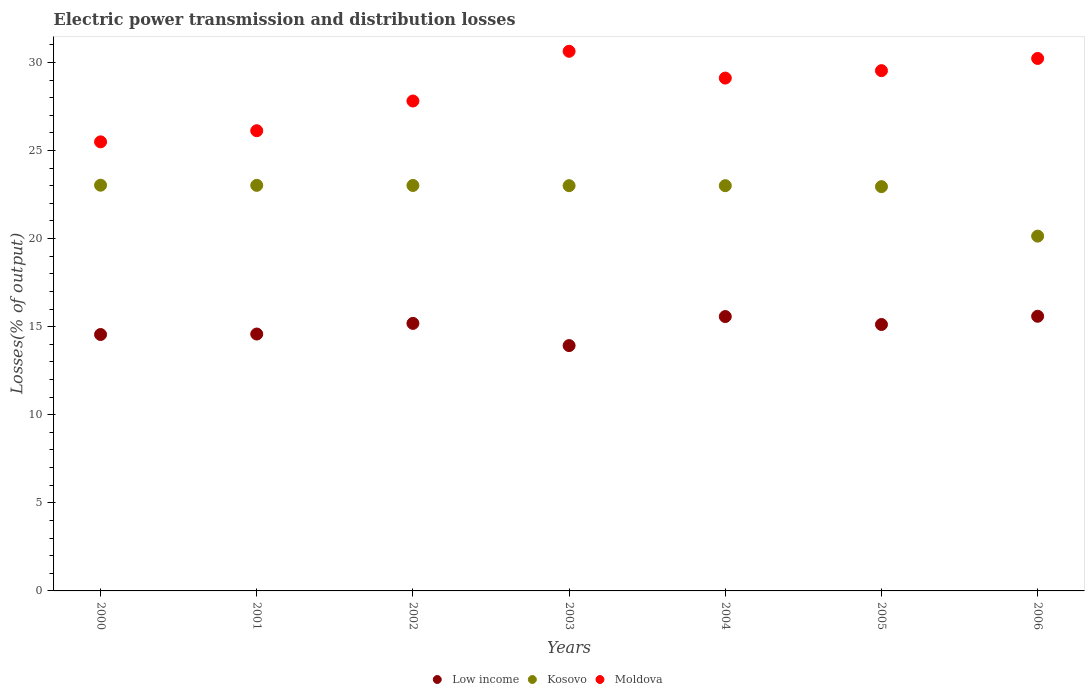Is the number of dotlines equal to the number of legend labels?
Offer a very short reply. Yes. What is the electric power transmission and distribution losses in Kosovo in 2002?
Provide a short and direct response. 23.01. Across all years, what is the maximum electric power transmission and distribution losses in Low income?
Your response must be concise. 15.59. Across all years, what is the minimum electric power transmission and distribution losses in Low income?
Keep it short and to the point. 13.93. In which year was the electric power transmission and distribution losses in Moldova maximum?
Offer a very short reply. 2003. What is the total electric power transmission and distribution losses in Moldova in the graph?
Give a very brief answer. 198.92. What is the difference between the electric power transmission and distribution losses in Low income in 2000 and that in 2006?
Provide a short and direct response. -1.04. What is the difference between the electric power transmission and distribution losses in Moldova in 2004 and the electric power transmission and distribution losses in Kosovo in 2001?
Your answer should be compact. 6.09. What is the average electric power transmission and distribution losses in Kosovo per year?
Make the answer very short. 22.59. In the year 2002, what is the difference between the electric power transmission and distribution losses in Low income and electric power transmission and distribution losses in Kosovo?
Keep it short and to the point. -7.83. In how many years, is the electric power transmission and distribution losses in Moldova greater than 4 %?
Your answer should be compact. 7. What is the ratio of the electric power transmission and distribution losses in Low income in 2003 to that in 2006?
Provide a succinct answer. 0.89. Is the electric power transmission and distribution losses in Kosovo in 2004 less than that in 2005?
Offer a very short reply. No. Is the difference between the electric power transmission and distribution losses in Low income in 2002 and 2004 greater than the difference between the electric power transmission and distribution losses in Kosovo in 2002 and 2004?
Give a very brief answer. No. What is the difference between the highest and the second highest electric power transmission and distribution losses in Moldova?
Ensure brevity in your answer.  0.41. What is the difference between the highest and the lowest electric power transmission and distribution losses in Kosovo?
Keep it short and to the point. 2.89. In how many years, is the electric power transmission and distribution losses in Moldova greater than the average electric power transmission and distribution losses in Moldova taken over all years?
Give a very brief answer. 4. Is the sum of the electric power transmission and distribution losses in Moldova in 2001 and 2002 greater than the maximum electric power transmission and distribution losses in Kosovo across all years?
Ensure brevity in your answer.  Yes. Does the electric power transmission and distribution losses in Moldova monotonically increase over the years?
Keep it short and to the point. No. Is the electric power transmission and distribution losses in Moldova strictly greater than the electric power transmission and distribution losses in Kosovo over the years?
Keep it short and to the point. Yes. How many dotlines are there?
Make the answer very short. 3. How many years are there in the graph?
Give a very brief answer. 7. What is the difference between two consecutive major ticks on the Y-axis?
Make the answer very short. 5. Does the graph contain any zero values?
Keep it short and to the point. No. What is the title of the graph?
Your answer should be very brief. Electric power transmission and distribution losses. What is the label or title of the X-axis?
Provide a succinct answer. Years. What is the label or title of the Y-axis?
Offer a terse response. Losses(% of output). What is the Losses(% of output) of Low income in 2000?
Keep it short and to the point. 14.55. What is the Losses(% of output) of Kosovo in 2000?
Your response must be concise. 23.03. What is the Losses(% of output) in Moldova in 2000?
Your answer should be very brief. 25.49. What is the Losses(% of output) of Low income in 2001?
Provide a succinct answer. 14.58. What is the Losses(% of output) in Kosovo in 2001?
Provide a succinct answer. 23.02. What is the Losses(% of output) of Moldova in 2001?
Offer a terse response. 26.12. What is the Losses(% of output) in Low income in 2002?
Provide a short and direct response. 15.19. What is the Losses(% of output) of Kosovo in 2002?
Offer a very short reply. 23.01. What is the Losses(% of output) in Moldova in 2002?
Keep it short and to the point. 27.81. What is the Losses(% of output) of Low income in 2003?
Your response must be concise. 13.93. What is the Losses(% of output) of Kosovo in 2003?
Keep it short and to the point. 23. What is the Losses(% of output) in Moldova in 2003?
Give a very brief answer. 30.63. What is the Losses(% of output) of Low income in 2004?
Make the answer very short. 15.57. What is the Losses(% of output) in Kosovo in 2004?
Provide a short and direct response. 23. What is the Losses(% of output) of Moldova in 2004?
Offer a terse response. 29.11. What is the Losses(% of output) of Low income in 2005?
Provide a short and direct response. 15.12. What is the Losses(% of output) of Kosovo in 2005?
Offer a very short reply. 22.95. What is the Losses(% of output) of Moldova in 2005?
Your response must be concise. 29.53. What is the Losses(% of output) of Low income in 2006?
Offer a very short reply. 15.59. What is the Losses(% of output) of Kosovo in 2006?
Ensure brevity in your answer.  20.14. What is the Losses(% of output) of Moldova in 2006?
Your response must be concise. 30.23. Across all years, what is the maximum Losses(% of output) in Low income?
Give a very brief answer. 15.59. Across all years, what is the maximum Losses(% of output) in Kosovo?
Provide a short and direct response. 23.03. Across all years, what is the maximum Losses(% of output) of Moldova?
Provide a succinct answer. 30.63. Across all years, what is the minimum Losses(% of output) of Low income?
Provide a succinct answer. 13.93. Across all years, what is the minimum Losses(% of output) of Kosovo?
Your response must be concise. 20.14. Across all years, what is the minimum Losses(% of output) in Moldova?
Your answer should be compact. 25.49. What is the total Losses(% of output) in Low income in the graph?
Your response must be concise. 104.54. What is the total Losses(% of output) in Kosovo in the graph?
Provide a succinct answer. 158.16. What is the total Losses(% of output) in Moldova in the graph?
Your answer should be very brief. 198.92. What is the difference between the Losses(% of output) of Low income in 2000 and that in 2001?
Offer a terse response. -0.03. What is the difference between the Losses(% of output) in Kosovo in 2000 and that in 2001?
Your response must be concise. 0.01. What is the difference between the Losses(% of output) in Moldova in 2000 and that in 2001?
Make the answer very short. -0.63. What is the difference between the Losses(% of output) in Low income in 2000 and that in 2002?
Provide a short and direct response. -0.63. What is the difference between the Losses(% of output) of Kosovo in 2000 and that in 2002?
Offer a terse response. 0.02. What is the difference between the Losses(% of output) in Moldova in 2000 and that in 2002?
Offer a terse response. -2.32. What is the difference between the Losses(% of output) in Low income in 2000 and that in 2003?
Give a very brief answer. 0.63. What is the difference between the Losses(% of output) of Kosovo in 2000 and that in 2003?
Provide a succinct answer. 0.03. What is the difference between the Losses(% of output) of Moldova in 2000 and that in 2003?
Provide a succinct answer. -5.14. What is the difference between the Losses(% of output) of Low income in 2000 and that in 2004?
Offer a very short reply. -1.02. What is the difference between the Losses(% of output) of Kosovo in 2000 and that in 2004?
Offer a very short reply. 0.03. What is the difference between the Losses(% of output) in Moldova in 2000 and that in 2004?
Offer a terse response. -3.62. What is the difference between the Losses(% of output) of Low income in 2000 and that in 2005?
Your answer should be very brief. -0.57. What is the difference between the Losses(% of output) of Kosovo in 2000 and that in 2005?
Give a very brief answer. 0.08. What is the difference between the Losses(% of output) of Moldova in 2000 and that in 2005?
Your answer should be very brief. -4.04. What is the difference between the Losses(% of output) in Low income in 2000 and that in 2006?
Make the answer very short. -1.04. What is the difference between the Losses(% of output) in Kosovo in 2000 and that in 2006?
Give a very brief answer. 2.89. What is the difference between the Losses(% of output) of Moldova in 2000 and that in 2006?
Your answer should be very brief. -4.73. What is the difference between the Losses(% of output) of Low income in 2001 and that in 2002?
Your answer should be very brief. -0.6. What is the difference between the Losses(% of output) of Kosovo in 2001 and that in 2002?
Your answer should be very brief. 0.01. What is the difference between the Losses(% of output) in Moldova in 2001 and that in 2002?
Your response must be concise. -1.69. What is the difference between the Losses(% of output) in Low income in 2001 and that in 2003?
Keep it short and to the point. 0.66. What is the difference between the Losses(% of output) of Kosovo in 2001 and that in 2003?
Make the answer very short. 0.02. What is the difference between the Losses(% of output) in Moldova in 2001 and that in 2003?
Offer a very short reply. -4.51. What is the difference between the Losses(% of output) of Low income in 2001 and that in 2004?
Your answer should be compact. -0.99. What is the difference between the Losses(% of output) in Kosovo in 2001 and that in 2004?
Your answer should be compact. 0.02. What is the difference between the Losses(% of output) in Moldova in 2001 and that in 2004?
Provide a short and direct response. -2.99. What is the difference between the Losses(% of output) in Low income in 2001 and that in 2005?
Give a very brief answer. -0.54. What is the difference between the Losses(% of output) in Kosovo in 2001 and that in 2005?
Keep it short and to the point. 0.07. What is the difference between the Losses(% of output) of Moldova in 2001 and that in 2005?
Keep it short and to the point. -3.41. What is the difference between the Losses(% of output) of Low income in 2001 and that in 2006?
Make the answer very short. -1.01. What is the difference between the Losses(% of output) in Kosovo in 2001 and that in 2006?
Your answer should be very brief. 2.88. What is the difference between the Losses(% of output) in Moldova in 2001 and that in 2006?
Give a very brief answer. -4.1. What is the difference between the Losses(% of output) in Low income in 2002 and that in 2003?
Ensure brevity in your answer.  1.26. What is the difference between the Losses(% of output) of Kosovo in 2002 and that in 2003?
Your answer should be compact. 0.01. What is the difference between the Losses(% of output) in Moldova in 2002 and that in 2003?
Ensure brevity in your answer.  -2.82. What is the difference between the Losses(% of output) in Low income in 2002 and that in 2004?
Offer a terse response. -0.39. What is the difference between the Losses(% of output) of Kosovo in 2002 and that in 2004?
Make the answer very short. 0.01. What is the difference between the Losses(% of output) of Moldova in 2002 and that in 2004?
Provide a short and direct response. -1.3. What is the difference between the Losses(% of output) in Low income in 2002 and that in 2005?
Provide a short and direct response. 0.06. What is the difference between the Losses(% of output) in Kosovo in 2002 and that in 2005?
Your answer should be compact. 0.07. What is the difference between the Losses(% of output) of Moldova in 2002 and that in 2005?
Ensure brevity in your answer.  -1.72. What is the difference between the Losses(% of output) in Low income in 2002 and that in 2006?
Make the answer very short. -0.4. What is the difference between the Losses(% of output) in Kosovo in 2002 and that in 2006?
Offer a terse response. 2.88. What is the difference between the Losses(% of output) of Moldova in 2002 and that in 2006?
Make the answer very short. -2.42. What is the difference between the Losses(% of output) in Low income in 2003 and that in 2004?
Your answer should be compact. -1.65. What is the difference between the Losses(% of output) in Kosovo in 2003 and that in 2004?
Offer a terse response. -0. What is the difference between the Losses(% of output) of Moldova in 2003 and that in 2004?
Your response must be concise. 1.52. What is the difference between the Losses(% of output) in Low income in 2003 and that in 2005?
Provide a succinct answer. -1.2. What is the difference between the Losses(% of output) in Kosovo in 2003 and that in 2005?
Give a very brief answer. 0.06. What is the difference between the Losses(% of output) in Moldova in 2003 and that in 2005?
Offer a very short reply. 1.1. What is the difference between the Losses(% of output) in Low income in 2003 and that in 2006?
Provide a succinct answer. -1.66. What is the difference between the Losses(% of output) of Kosovo in 2003 and that in 2006?
Keep it short and to the point. 2.86. What is the difference between the Losses(% of output) in Moldova in 2003 and that in 2006?
Offer a terse response. 0.41. What is the difference between the Losses(% of output) of Low income in 2004 and that in 2005?
Give a very brief answer. 0.45. What is the difference between the Losses(% of output) in Kosovo in 2004 and that in 2005?
Keep it short and to the point. 0.06. What is the difference between the Losses(% of output) of Moldova in 2004 and that in 2005?
Your answer should be very brief. -0.42. What is the difference between the Losses(% of output) in Low income in 2004 and that in 2006?
Offer a terse response. -0.02. What is the difference between the Losses(% of output) in Kosovo in 2004 and that in 2006?
Your answer should be compact. 2.86. What is the difference between the Losses(% of output) of Moldova in 2004 and that in 2006?
Provide a succinct answer. -1.11. What is the difference between the Losses(% of output) in Low income in 2005 and that in 2006?
Make the answer very short. -0.47. What is the difference between the Losses(% of output) in Kosovo in 2005 and that in 2006?
Make the answer very short. 2.81. What is the difference between the Losses(% of output) in Moldova in 2005 and that in 2006?
Make the answer very short. -0.69. What is the difference between the Losses(% of output) in Low income in 2000 and the Losses(% of output) in Kosovo in 2001?
Give a very brief answer. -8.47. What is the difference between the Losses(% of output) in Low income in 2000 and the Losses(% of output) in Moldova in 2001?
Provide a short and direct response. -11.57. What is the difference between the Losses(% of output) in Kosovo in 2000 and the Losses(% of output) in Moldova in 2001?
Make the answer very short. -3.09. What is the difference between the Losses(% of output) in Low income in 2000 and the Losses(% of output) in Kosovo in 2002?
Make the answer very short. -8.46. What is the difference between the Losses(% of output) in Low income in 2000 and the Losses(% of output) in Moldova in 2002?
Your answer should be compact. -13.25. What is the difference between the Losses(% of output) in Kosovo in 2000 and the Losses(% of output) in Moldova in 2002?
Ensure brevity in your answer.  -4.78. What is the difference between the Losses(% of output) of Low income in 2000 and the Losses(% of output) of Kosovo in 2003?
Your response must be concise. -8.45. What is the difference between the Losses(% of output) in Low income in 2000 and the Losses(% of output) in Moldova in 2003?
Make the answer very short. -16.08. What is the difference between the Losses(% of output) of Kosovo in 2000 and the Losses(% of output) of Moldova in 2003?
Your answer should be compact. -7.6. What is the difference between the Losses(% of output) in Low income in 2000 and the Losses(% of output) in Kosovo in 2004?
Ensure brevity in your answer.  -8.45. What is the difference between the Losses(% of output) of Low income in 2000 and the Losses(% of output) of Moldova in 2004?
Your response must be concise. -14.56. What is the difference between the Losses(% of output) of Kosovo in 2000 and the Losses(% of output) of Moldova in 2004?
Ensure brevity in your answer.  -6.08. What is the difference between the Losses(% of output) of Low income in 2000 and the Losses(% of output) of Kosovo in 2005?
Ensure brevity in your answer.  -8.39. What is the difference between the Losses(% of output) in Low income in 2000 and the Losses(% of output) in Moldova in 2005?
Offer a very short reply. -14.98. What is the difference between the Losses(% of output) of Kosovo in 2000 and the Losses(% of output) of Moldova in 2005?
Offer a very short reply. -6.5. What is the difference between the Losses(% of output) of Low income in 2000 and the Losses(% of output) of Kosovo in 2006?
Ensure brevity in your answer.  -5.59. What is the difference between the Losses(% of output) in Low income in 2000 and the Losses(% of output) in Moldova in 2006?
Offer a very short reply. -15.67. What is the difference between the Losses(% of output) of Kosovo in 2000 and the Losses(% of output) of Moldova in 2006?
Give a very brief answer. -7.2. What is the difference between the Losses(% of output) in Low income in 2001 and the Losses(% of output) in Kosovo in 2002?
Provide a succinct answer. -8.43. What is the difference between the Losses(% of output) of Low income in 2001 and the Losses(% of output) of Moldova in 2002?
Keep it short and to the point. -13.23. What is the difference between the Losses(% of output) of Kosovo in 2001 and the Losses(% of output) of Moldova in 2002?
Your answer should be very brief. -4.79. What is the difference between the Losses(% of output) in Low income in 2001 and the Losses(% of output) in Kosovo in 2003?
Provide a short and direct response. -8.42. What is the difference between the Losses(% of output) in Low income in 2001 and the Losses(% of output) in Moldova in 2003?
Make the answer very short. -16.05. What is the difference between the Losses(% of output) in Kosovo in 2001 and the Losses(% of output) in Moldova in 2003?
Provide a succinct answer. -7.61. What is the difference between the Losses(% of output) of Low income in 2001 and the Losses(% of output) of Kosovo in 2004?
Ensure brevity in your answer.  -8.42. What is the difference between the Losses(% of output) in Low income in 2001 and the Losses(% of output) in Moldova in 2004?
Provide a succinct answer. -14.53. What is the difference between the Losses(% of output) in Kosovo in 2001 and the Losses(% of output) in Moldova in 2004?
Offer a terse response. -6.09. What is the difference between the Losses(% of output) of Low income in 2001 and the Losses(% of output) of Kosovo in 2005?
Give a very brief answer. -8.37. What is the difference between the Losses(% of output) of Low income in 2001 and the Losses(% of output) of Moldova in 2005?
Your answer should be compact. -14.95. What is the difference between the Losses(% of output) in Kosovo in 2001 and the Losses(% of output) in Moldova in 2005?
Your answer should be very brief. -6.51. What is the difference between the Losses(% of output) of Low income in 2001 and the Losses(% of output) of Kosovo in 2006?
Make the answer very short. -5.56. What is the difference between the Losses(% of output) in Low income in 2001 and the Losses(% of output) in Moldova in 2006?
Ensure brevity in your answer.  -15.64. What is the difference between the Losses(% of output) of Kosovo in 2001 and the Losses(% of output) of Moldova in 2006?
Your answer should be compact. -7.2. What is the difference between the Losses(% of output) of Low income in 2002 and the Losses(% of output) of Kosovo in 2003?
Your answer should be very brief. -7.82. What is the difference between the Losses(% of output) of Low income in 2002 and the Losses(% of output) of Moldova in 2003?
Provide a succinct answer. -15.45. What is the difference between the Losses(% of output) in Kosovo in 2002 and the Losses(% of output) in Moldova in 2003?
Make the answer very short. -7.62. What is the difference between the Losses(% of output) of Low income in 2002 and the Losses(% of output) of Kosovo in 2004?
Provide a short and direct response. -7.82. What is the difference between the Losses(% of output) of Low income in 2002 and the Losses(% of output) of Moldova in 2004?
Offer a very short reply. -13.92. What is the difference between the Losses(% of output) of Kosovo in 2002 and the Losses(% of output) of Moldova in 2004?
Provide a succinct answer. -6.1. What is the difference between the Losses(% of output) of Low income in 2002 and the Losses(% of output) of Kosovo in 2005?
Provide a short and direct response. -7.76. What is the difference between the Losses(% of output) of Low income in 2002 and the Losses(% of output) of Moldova in 2005?
Provide a short and direct response. -14.35. What is the difference between the Losses(% of output) in Kosovo in 2002 and the Losses(% of output) in Moldova in 2005?
Ensure brevity in your answer.  -6.52. What is the difference between the Losses(% of output) in Low income in 2002 and the Losses(% of output) in Kosovo in 2006?
Your response must be concise. -4.95. What is the difference between the Losses(% of output) in Low income in 2002 and the Losses(% of output) in Moldova in 2006?
Offer a very short reply. -15.04. What is the difference between the Losses(% of output) in Kosovo in 2002 and the Losses(% of output) in Moldova in 2006?
Ensure brevity in your answer.  -7.21. What is the difference between the Losses(% of output) in Low income in 2003 and the Losses(% of output) in Kosovo in 2004?
Offer a terse response. -9.08. What is the difference between the Losses(% of output) of Low income in 2003 and the Losses(% of output) of Moldova in 2004?
Keep it short and to the point. -15.18. What is the difference between the Losses(% of output) in Kosovo in 2003 and the Losses(% of output) in Moldova in 2004?
Your answer should be compact. -6.11. What is the difference between the Losses(% of output) in Low income in 2003 and the Losses(% of output) in Kosovo in 2005?
Offer a terse response. -9.02. What is the difference between the Losses(% of output) in Low income in 2003 and the Losses(% of output) in Moldova in 2005?
Offer a very short reply. -15.61. What is the difference between the Losses(% of output) in Kosovo in 2003 and the Losses(% of output) in Moldova in 2005?
Make the answer very short. -6.53. What is the difference between the Losses(% of output) in Low income in 2003 and the Losses(% of output) in Kosovo in 2006?
Provide a short and direct response. -6.21. What is the difference between the Losses(% of output) of Low income in 2003 and the Losses(% of output) of Moldova in 2006?
Provide a succinct answer. -16.3. What is the difference between the Losses(% of output) in Kosovo in 2003 and the Losses(% of output) in Moldova in 2006?
Ensure brevity in your answer.  -7.22. What is the difference between the Losses(% of output) of Low income in 2004 and the Losses(% of output) of Kosovo in 2005?
Keep it short and to the point. -7.37. What is the difference between the Losses(% of output) in Low income in 2004 and the Losses(% of output) in Moldova in 2005?
Offer a terse response. -13.96. What is the difference between the Losses(% of output) in Kosovo in 2004 and the Losses(% of output) in Moldova in 2005?
Offer a very short reply. -6.53. What is the difference between the Losses(% of output) in Low income in 2004 and the Losses(% of output) in Kosovo in 2006?
Your response must be concise. -4.57. What is the difference between the Losses(% of output) of Low income in 2004 and the Losses(% of output) of Moldova in 2006?
Your answer should be compact. -14.65. What is the difference between the Losses(% of output) of Kosovo in 2004 and the Losses(% of output) of Moldova in 2006?
Your answer should be very brief. -7.22. What is the difference between the Losses(% of output) in Low income in 2005 and the Losses(% of output) in Kosovo in 2006?
Your answer should be compact. -5.02. What is the difference between the Losses(% of output) in Low income in 2005 and the Losses(% of output) in Moldova in 2006?
Give a very brief answer. -15.1. What is the difference between the Losses(% of output) of Kosovo in 2005 and the Losses(% of output) of Moldova in 2006?
Ensure brevity in your answer.  -7.28. What is the average Losses(% of output) in Low income per year?
Your response must be concise. 14.93. What is the average Losses(% of output) in Kosovo per year?
Provide a short and direct response. 22.59. What is the average Losses(% of output) in Moldova per year?
Offer a terse response. 28.42. In the year 2000, what is the difference between the Losses(% of output) of Low income and Losses(% of output) of Kosovo?
Your answer should be compact. -8.48. In the year 2000, what is the difference between the Losses(% of output) of Low income and Losses(% of output) of Moldova?
Keep it short and to the point. -10.94. In the year 2000, what is the difference between the Losses(% of output) of Kosovo and Losses(% of output) of Moldova?
Ensure brevity in your answer.  -2.46. In the year 2001, what is the difference between the Losses(% of output) in Low income and Losses(% of output) in Kosovo?
Give a very brief answer. -8.44. In the year 2001, what is the difference between the Losses(% of output) of Low income and Losses(% of output) of Moldova?
Offer a very short reply. -11.54. In the year 2001, what is the difference between the Losses(% of output) in Kosovo and Losses(% of output) in Moldova?
Provide a succinct answer. -3.1. In the year 2002, what is the difference between the Losses(% of output) in Low income and Losses(% of output) in Kosovo?
Offer a terse response. -7.83. In the year 2002, what is the difference between the Losses(% of output) of Low income and Losses(% of output) of Moldova?
Provide a short and direct response. -12.62. In the year 2002, what is the difference between the Losses(% of output) of Kosovo and Losses(% of output) of Moldova?
Provide a succinct answer. -4.79. In the year 2003, what is the difference between the Losses(% of output) in Low income and Losses(% of output) in Kosovo?
Ensure brevity in your answer.  -9.08. In the year 2003, what is the difference between the Losses(% of output) of Low income and Losses(% of output) of Moldova?
Provide a succinct answer. -16.71. In the year 2003, what is the difference between the Losses(% of output) of Kosovo and Losses(% of output) of Moldova?
Your answer should be compact. -7.63. In the year 2004, what is the difference between the Losses(% of output) in Low income and Losses(% of output) in Kosovo?
Keep it short and to the point. -7.43. In the year 2004, what is the difference between the Losses(% of output) in Low income and Losses(% of output) in Moldova?
Ensure brevity in your answer.  -13.54. In the year 2004, what is the difference between the Losses(% of output) in Kosovo and Losses(% of output) in Moldova?
Your answer should be compact. -6.11. In the year 2005, what is the difference between the Losses(% of output) of Low income and Losses(% of output) of Kosovo?
Your answer should be very brief. -7.82. In the year 2005, what is the difference between the Losses(% of output) in Low income and Losses(% of output) in Moldova?
Your response must be concise. -14.41. In the year 2005, what is the difference between the Losses(% of output) in Kosovo and Losses(% of output) in Moldova?
Offer a very short reply. -6.58. In the year 2006, what is the difference between the Losses(% of output) of Low income and Losses(% of output) of Kosovo?
Ensure brevity in your answer.  -4.55. In the year 2006, what is the difference between the Losses(% of output) in Low income and Losses(% of output) in Moldova?
Ensure brevity in your answer.  -14.63. In the year 2006, what is the difference between the Losses(% of output) in Kosovo and Losses(% of output) in Moldova?
Keep it short and to the point. -10.09. What is the ratio of the Losses(% of output) of Moldova in 2000 to that in 2001?
Ensure brevity in your answer.  0.98. What is the ratio of the Losses(% of output) in Low income in 2000 to that in 2002?
Give a very brief answer. 0.96. What is the ratio of the Losses(% of output) in Moldova in 2000 to that in 2002?
Offer a very short reply. 0.92. What is the ratio of the Losses(% of output) in Low income in 2000 to that in 2003?
Keep it short and to the point. 1.05. What is the ratio of the Losses(% of output) of Kosovo in 2000 to that in 2003?
Provide a short and direct response. 1. What is the ratio of the Losses(% of output) in Moldova in 2000 to that in 2003?
Offer a very short reply. 0.83. What is the ratio of the Losses(% of output) of Low income in 2000 to that in 2004?
Offer a very short reply. 0.93. What is the ratio of the Losses(% of output) of Kosovo in 2000 to that in 2004?
Your answer should be very brief. 1. What is the ratio of the Losses(% of output) of Moldova in 2000 to that in 2004?
Your answer should be very brief. 0.88. What is the ratio of the Losses(% of output) of Low income in 2000 to that in 2005?
Your answer should be compact. 0.96. What is the ratio of the Losses(% of output) of Moldova in 2000 to that in 2005?
Offer a terse response. 0.86. What is the ratio of the Losses(% of output) in Low income in 2000 to that in 2006?
Keep it short and to the point. 0.93. What is the ratio of the Losses(% of output) of Kosovo in 2000 to that in 2006?
Your answer should be compact. 1.14. What is the ratio of the Losses(% of output) in Moldova in 2000 to that in 2006?
Give a very brief answer. 0.84. What is the ratio of the Losses(% of output) in Low income in 2001 to that in 2002?
Offer a terse response. 0.96. What is the ratio of the Losses(% of output) in Moldova in 2001 to that in 2002?
Keep it short and to the point. 0.94. What is the ratio of the Losses(% of output) of Low income in 2001 to that in 2003?
Your answer should be compact. 1.05. What is the ratio of the Losses(% of output) of Moldova in 2001 to that in 2003?
Your response must be concise. 0.85. What is the ratio of the Losses(% of output) of Low income in 2001 to that in 2004?
Offer a terse response. 0.94. What is the ratio of the Losses(% of output) of Kosovo in 2001 to that in 2004?
Provide a succinct answer. 1. What is the ratio of the Losses(% of output) of Moldova in 2001 to that in 2004?
Ensure brevity in your answer.  0.9. What is the ratio of the Losses(% of output) of Low income in 2001 to that in 2005?
Offer a terse response. 0.96. What is the ratio of the Losses(% of output) of Moldova in 2001 to that in 2005?
Your answer should be compact. 0.88. What is the ratio of the Losses(% of output) in Low income in 2001 to that in 2006?
Provide a succinct answer. 0.94. What is the ratio of the Losses(% of output) of Kosovo in 2001 to that in 2006?
Your response must be concise. 1.14. What is the ratio of the Losses(% of output) of Moldova in 2001 to that in 2006?
Provide a short and direct response. 0.86. What is the ratio of the Losses(% of output) of Low income in 2002 to that in 2003?
Make the answer very short. 1.09. What is the ratio of the Losses(% of output) in Moldova in 2002 to that in 2003?
Your response must be concise. 0.91. What is the ratio of the Losses(% of output) of Low income in 2002 to that in 2004?
Your answer should be compact. 0.98. What is the ratio of the Losses(% of output) of Kosovo in 2002 to that in 2004?
Offer a very short reply. 1. What is the ratio of the Losses(% of output) in Moldova in 2002 to that in 2004?
Offer a terse response. 0.96. What is the ratio of the Losses(% of output) of Low income in 2002 to that in 2005?
Provide a short and direct response. 1. What is the ratio of the Losses(% of output) of Moldova in 2002 to that in 2005?
Make the answer very short. 0.94. What is the ratio of the Losses(% of output) in Low income in 2002 to that in 2006?
Your response must be concise. 0.97. What is the ratio of the Losses(% of output) of Kosovo in 2002 to that in 2006?
Ensure brevity in your answer.  1.14. What is the ratio of the Losses(% of output) in Moldova in 2002 to that in 2006?
Your answer should be very brief. 0.92. What is the ratio of the Losses(% of output) in Low income in 2003 to that in 2004?
Offer a very short reply. 0.89. What is the ratio of the Losses(% of output) in Moldova in 2003 to that in 2004?
Provide a short and direct response. 1.05. What is the ratio of the Losses(% of output) of Low income in 2003 to that in 2005?
Make the answer very short. 0.92. What is the ratio of the Losses(% of output) of Kosovo in 2003 to that in 2005?
Ensure brevity in your answer.  1. What is the ratio of the Losses(% of output) in Moldova in 2003 to that in 2005?
Offer a very short reply. 1.04. What is the ratio of the Losses(% of output) in Low income in 2003 to that in 2006?
Your answer should be very brief. 0.89. What is the ratio of the Losses(% of output) of Kosovo in 2003 to that in 2006?
Offer a very short reply. 1.14. What is the ratio of the Losses(% of output) in Moldova in 2003 to that in 2006?
Ensure brevity in your answer.  1.01. What is the ratio of the Losses(% of output) of Low income in 2004 to that in 2005?
Your answer should be compact. 1.03. What is the ratio of the Losses(% of output) in Moldova in 2004 to that in 2005?
Your answer should be compact. 0.99. What is the ratio of the Losses(% of output) in Kosovo in 2004 to that in 2006?
Your answer should be compact. 1.14. What is the ratio of the Losses(% of output) in Moldova in 2004 to that in 2006?
Ensure brevity in your answer.  0.96. What is the ratio of the Losses(% of output) of Kosovo in 2005 to that in 2006?
Your response must be concise. 1.14. What is the ratio of the Losses(% of output) of Moldova in 2005 to that in 2006?
Make the answer very short. 0.98. What is the difference between the highest and the second highest Losses(% of output) of Low income?
Keep it short and to the point. 0.02. What is the difference between the highest and the second highest Losses(% of output) of Kosovo?
Keep it short and to the point. 0.01. What is the difference between the highest and the second highest Losses(% of output) in Moldova?
Offer a very short reply. 0.41. What is the difference between the highest and the lowest Losses(% of output) in Low income?
Provide a short and direct response. 1.66. What is the difference between the highest and the lowest Losses(% of output) of Kosovo?
Give a very brief answer. 2.89. What is the difference between the highest and the lowest Losses(% of output) in Moldova?
Offer a very short reply. 5.14. 